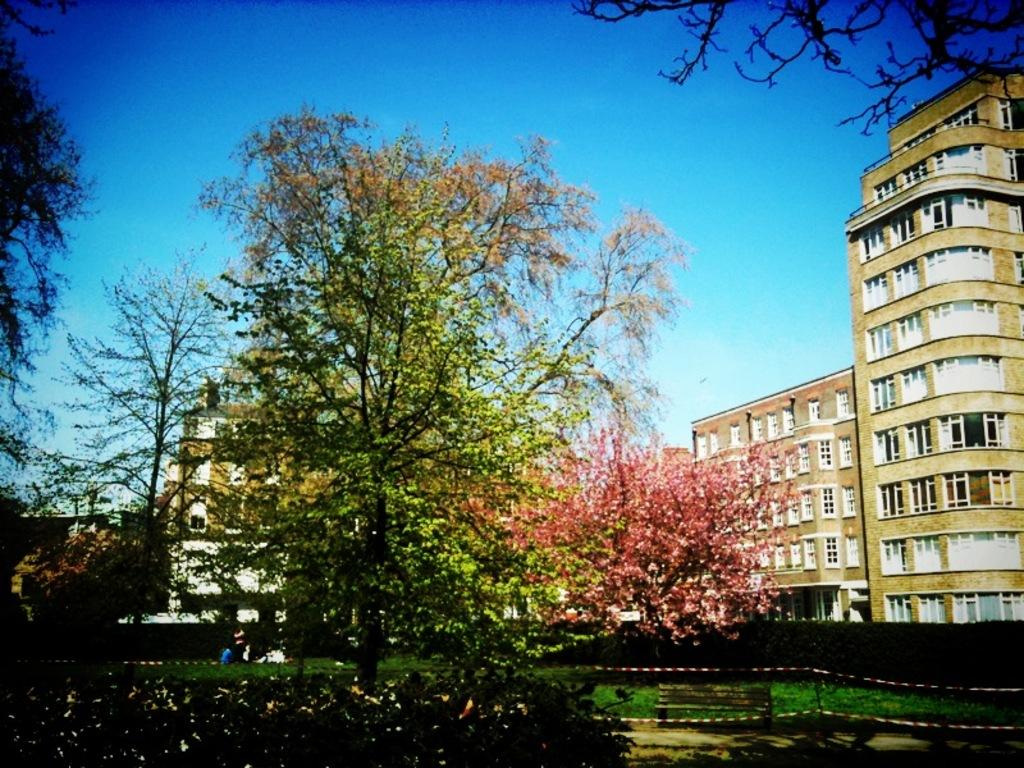What is located in the center of the image? There are trees in the center of the image. What can be seen in the background of the image? There are buildings in the background of the image. What type of vegetation is at the bottom of the image? There is grass at the bottom of the image. What piece of furniture is present in the image? There is a bench in the image. How many frogs are sitting on the bench in the image? There are no frogs present in the image; it features trees, buildings, grass, and a bench. What type of holiday is being celebrated in the image? There is no indication of a holiday being celebrated in the image. 